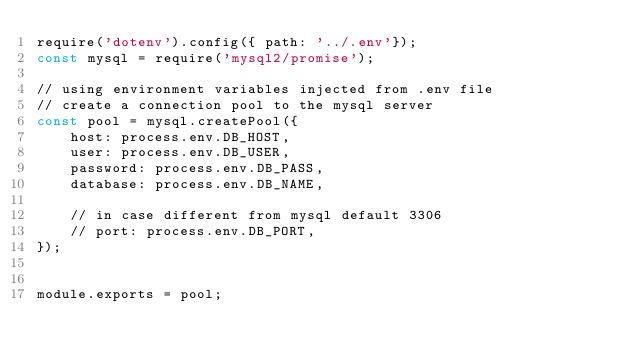Convert code to text. <code><loc_0><loc_0><loc_500><loc_500><_JavaScript_>require('dotenv').config({ path: '../.env'});
const mysql = require('mysql2/promise');

// using environment variables injected from .env file
// create a connection pool to the mysql server
const pool = mysql.createPool({
    host: process.env.DB_HOST,
    user: process.env.DB_USER,
    password: process.env.DB_PASS,
    database: process.env.DB_NAME,

    // in case different from mysql default 3306
    // port: process.env.DB_PORT, 
});


module.exports = pool;</code> 